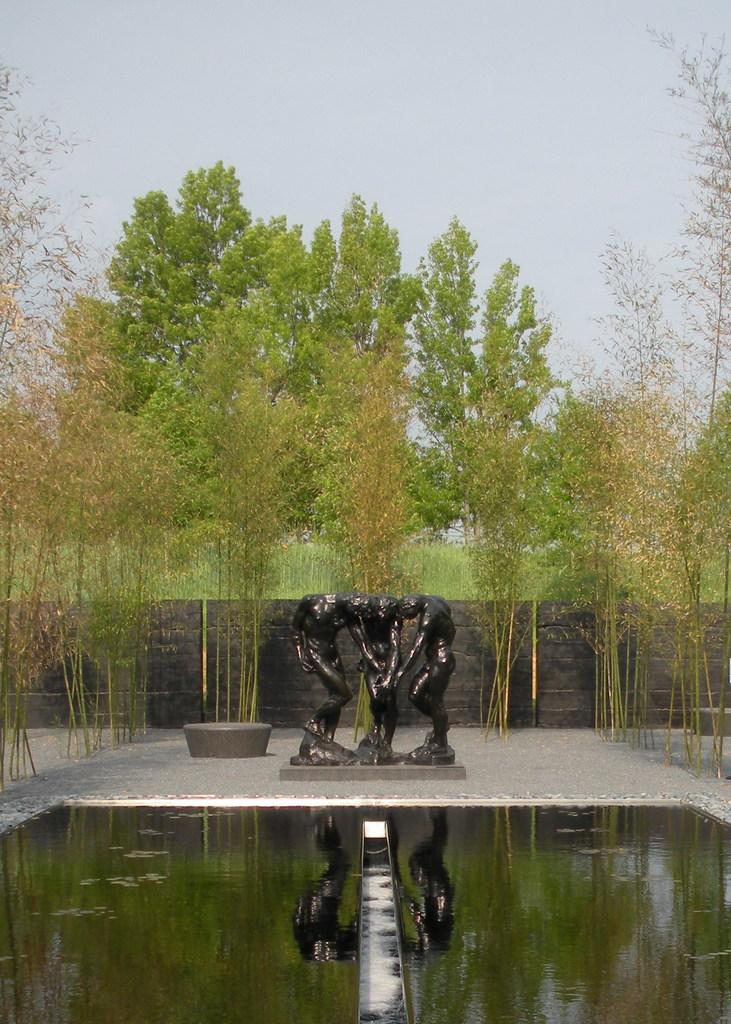What type of art is visible in the image? There are sculptures in the image. What natural element is present in the image? There is water in the image. What type of vegetation is in the image? Trees are present in the image. What type of structure is in the image? There is a wall in the image. What can be seen in the water in the image? The water has a reflection in it. What is visible in the background of the image? The sky is visible in the background of the image. Can you see any fish swimming in the water in the image? There are no fish visible in the image; it only shows sculptures, water, trees, a wall, and a reflection in the water. Is there a hat on any of the sculptures in the image? There is no hat present on any of the sculptures in the image. 